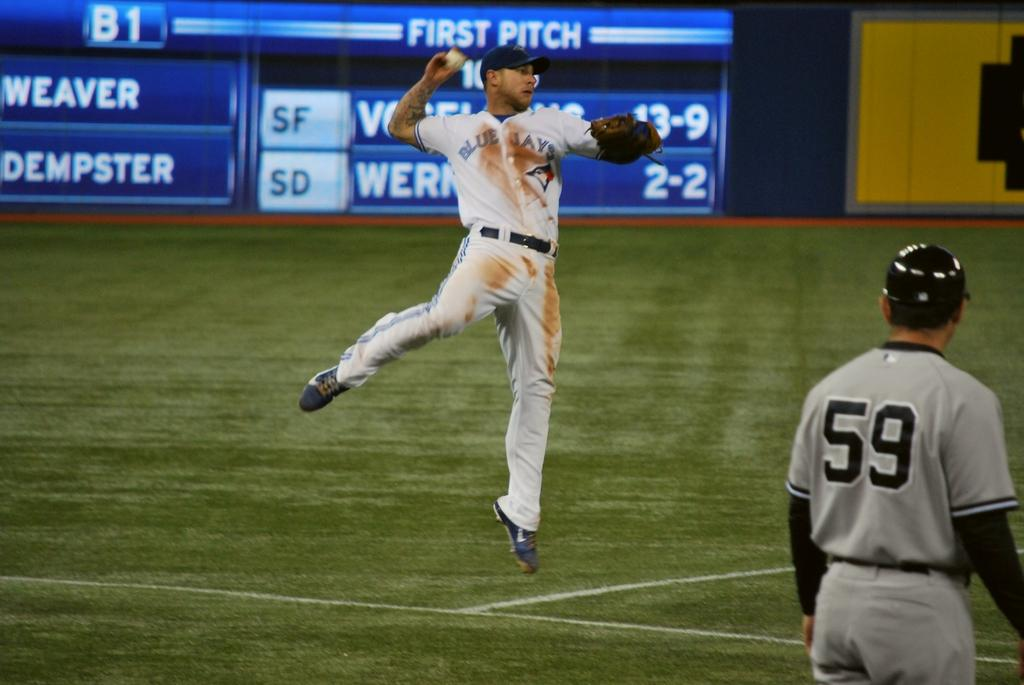<image>
Write a terse but informative summary of the picture. a person with the number 59 on their jersey 